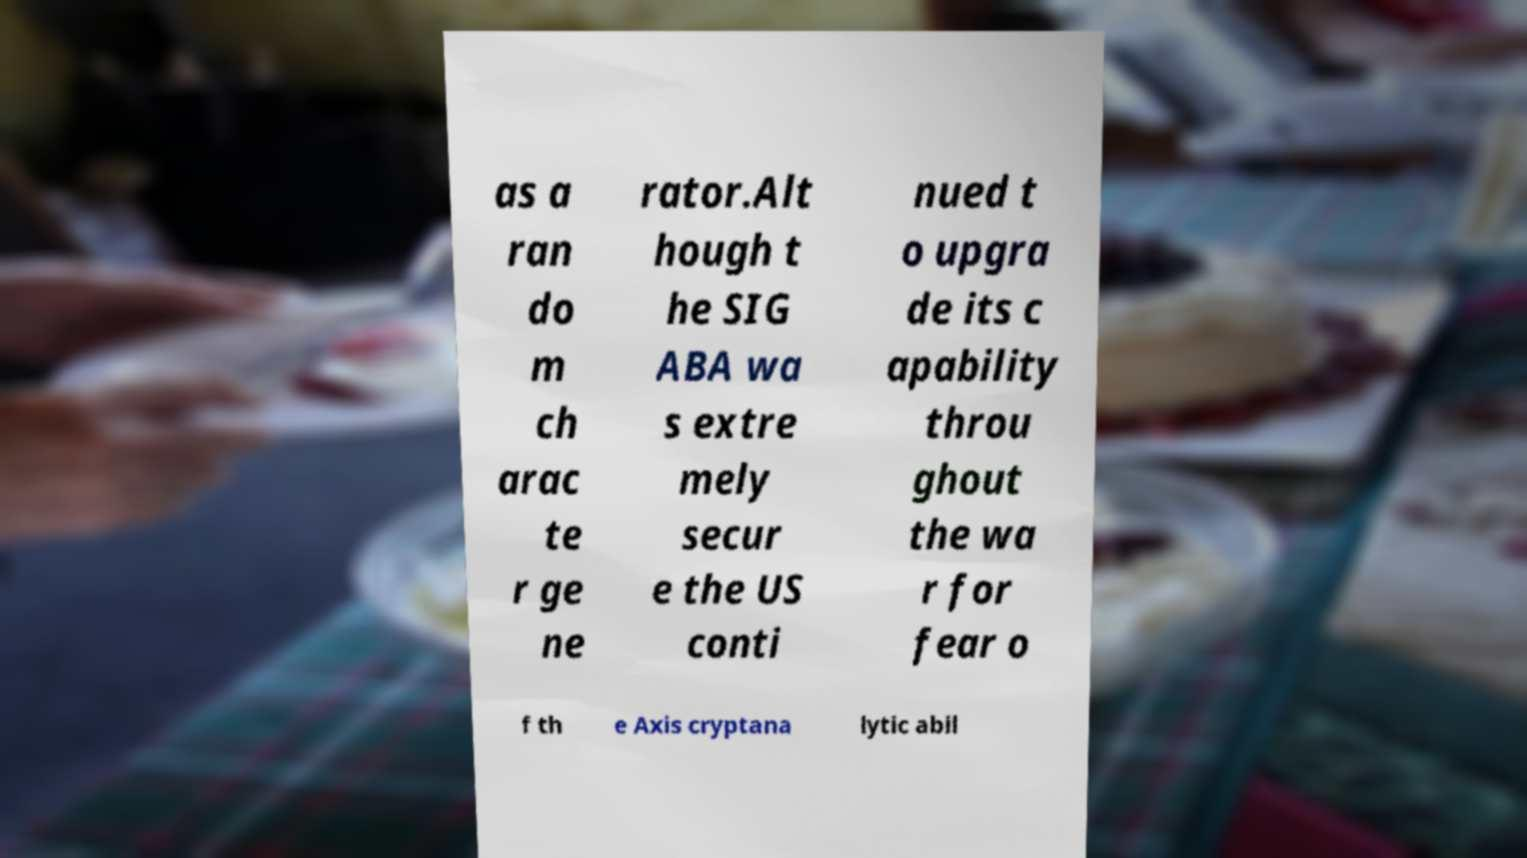What messages or text are displayed in this image? I need them in a readable, typed format. as a ran do m ch arac te r ge ne rator.Alt hough t he SIG ABA wa s extre mely secur e the US conti nued t o upgra de its c apability throu ghout the wa r for fear o f th e Axis cryptana lytic abil 